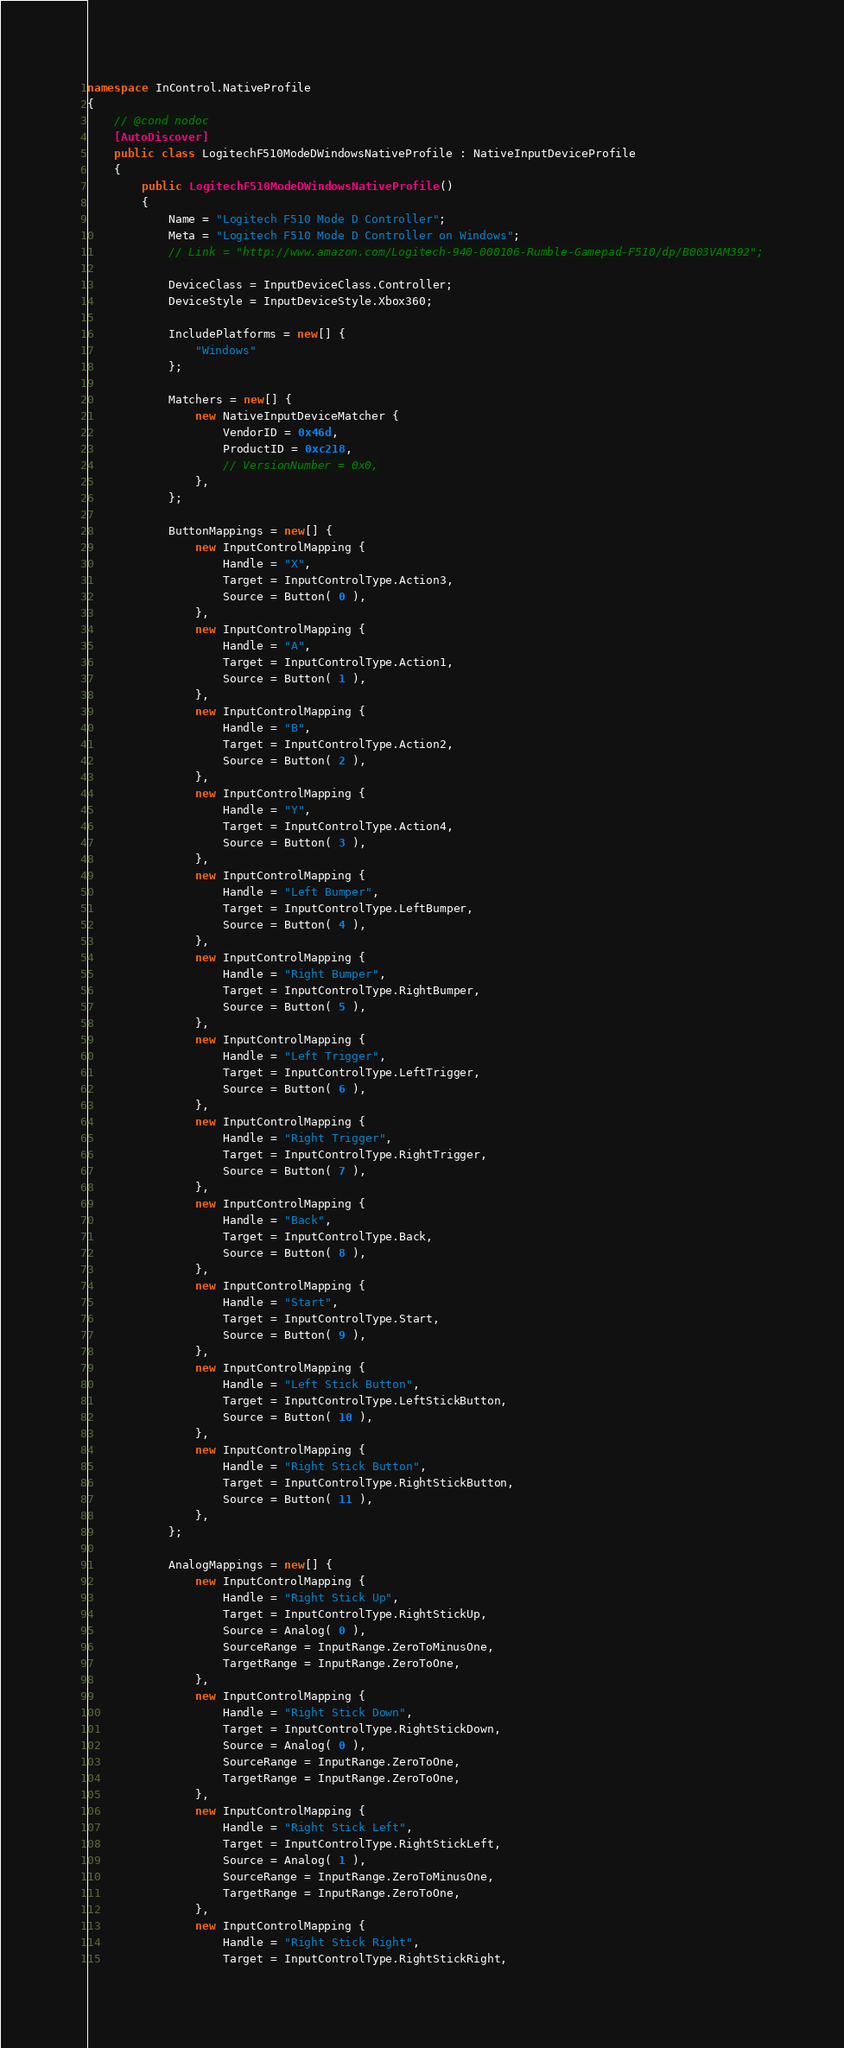Convert code to text. <code><loc_0><loc_0><loc_500><loc_500><_C#_>namespace InControl.NativeProfile
{
	// @cond nodoc
	[AutoDiscover]
	public class LogitechF510ModeDWindowsNativeProfile : NativeInputDeviceProfile
	{
		public LogitechF510ModeDWindowsNativeProfile()
		{
			Name = "Logitech F510 Mode D Controller";
			Meta = "Logitech F510 Mode D Controller on Windows";
			// Link = "http://www.amazon.com/Logitech-940-000106-Rumble-Gamepad-F510/dp/B003VAM392";

			DeviceClass = InputDeviceClass.Controller;
			DeviceStyle = InputDeviceStyle.Xbox360;

			IncludePlatforms = new[] {
				"Windows"
			};

			Matchers = new[] {
				new NativeInputDeviceMatcher {
					VendorID = 0x46d,
					ProductID = 0xc218,
					// VersionNumber = 0x0,
				},
			};

			ButtonMappings = new[] {
				new InputControlMapping {
					Handle = "X",
					Target = InputControlType.Action3,
					Source = Button( 0 ),
				},
				new InputControlMapping {
					Handle = "A",
					Target = InputControlType.Action1,
					Source = Button( 1 ),
				},
				new InputControlMapping {
					Handle = "B",
					Target = InputControlType.Action2,
					Source = Button( 2 ),
				},
				new InputControlMapping {
					Handle = "Y",
					Target = InputControlType.Action4,
					Source = Button( 3 ),
				},
				new InputControlMapping {
					Handle = "Left Bumper",
					Target = InputControlType.LeftBumper,
					Source = Button( 4 ),
				},
				new InputControlMapping {
					Handle = "Right Bumper",
					Target = InputControlType.RightBumper,
					Source = Button( 5 ),
				},
				new InputControlMapping {
					Handle = "Left Trigger",
					Target = InputControlType.LeftTrigger,
					Source = Button( 6 ),
				},
				new InputControlMapping {
					Handle = "Right Trigger",
					Target = InputControlType.RightTrigger,
					Source = Button( 7 ),
				},
				new InputControlMapping {
					Handle = "Back",
					Target = InputControlType.Back,
					Source = Button( 8 ),
				},
				new InputControlMapping {
					Handle = "Start",
					Target = InputControlType.Start,
					Source = Button( 9 ),
				},
				new InputControlMapping {
					Handle = "Left Stick Button",
					Target = InputControlType.LeftStickButton,
					Source = Button( 10 ),
				},
				new InputControlMapping {
					Handle = "Right Stick Button",
					Target = InputControlType.RightStickButton,
					Source = Button( 11 ),
				},
			};

			AnalogMappings = new[] {
				new InputControlMapping {
					Handle = "Right Stick Up",
					Target = InputControlType.RightStickUp,
					Source = Analog( 0 ),
					SourceRange = InputRange.ZeroToMinusOne,
					TargetRange = InputRange.ZeroToOne,
				},
				new InputControlMapping {
					Handle = "Right Stick Down",
					Target = InputControlType.RightStickDown,
					Source = Analog( 0 ),
					SourceRange = InputRange.ZeroToOne,
					TargetRange = InputRange.ZeroToOne,
				},
				new InputControlMapping {
					Handle = "Right Stick Left",
					Target = InputControlType.RightStickLeft,
					Source = Analog( 1 ),
					SourceRange = InputRange.ZeroToMinusOne,
					TargetRange = InputRange.ZeroToOne,
				},
				new InputControlMapping {
					Handle = "Right Stick Right",
					Target = InputControlType.RightStickRight,</code> 